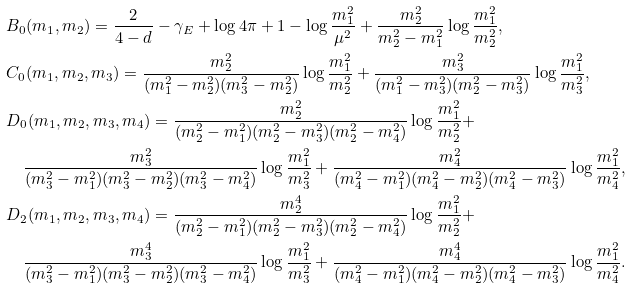Convert formula to latex. <formula><loc_0><loc_0><loc_500><loc_500>& B _ { 0 } ( m _ { 1 } , m _ { 2 } ) = \frac { 2 } { 4 - d } - \gamma _ { E } + \log 4 \pi + 1 - \log \frac { m _ { 1 } ^ { 2 } } { \mu ^ { 2 } } + \frac { m _ { 2 } ^ { 2 } } { m _ { 2 } ^ { 2 } - m _ { 1 } ^ { 2 } } \log \frac { m _ { 1 } ^ { 2 } } { m _ { 2 } ^ { 2 } } , \\ & C _ { 0 } ( m _ { 1 } , m _ { 2 } , m _ { 3 } ) = \frac { m _ { 2 } ^ { 2 } } { ( m _ { 1 } ^ { 2 } - m _ { 2 } ^ { 2 } ) ( m _ { 3 } ^ { 2 } - m _ { 2 } ^ { 2 } ) } \log \frac { m _ { 1 } ^ { 2 } } { m _ { 2 } ^ { 2 } } + \frac { m _ { 3 } ^ { 2 } } { ( m _ { 1 } ^ { 2 } - m _ { 3 } ^ { 2 } ) ( m _ { 2 } ^ { 2 } - m _ { 3 } ^ { 2 } ) } \log \frac { m _ { 1 } ^ { 2 } } { m _ { 3 } ^ { 2 } } , \\ & D _ { 0 } ( m _ { 1 } , m _ { 2 } , m _ { 3 } , m _ { 4 } ) = \frac { m _ { 2 } ^ { 2 } } { ( m _ { 2 } ^ { 2 } - m _ { 1 } ^ { 2 } ) ( m _ { 2 } ^ { 2 } - m _ { 3 } ^ { 2 } ) ( m _ { 2 } ^ { 2 } - m _ { 4 } ^ { 2 } ) } \log \frac { m _ { 1 } ^ { 2 } } { m _ { 2 } ^ { 2 } } + \\ & \quad \frac { m _ { 3 } ^ { 2 } } { ( m _ { 3 } ^ { 2 } - m _ { 1 } ^ { 2 } ) ( m _ { 3 } ^ { 2 } - m _ { 2 } ^ { 2 } ) ( m _ { 3 } ^ { 2 } - m _ { 4 } ^ { 2 } ) } \log \frac { m _ { 1 } ^ { 2 } } { m _ { 3 } ^ { 2 } } + \frac { m _ { 4 } ^ { 2 } } { ( m _ { 4 } ^ { 2 } - m _ { 1 } ^ { 2 } ) ( m _ { 4 } ^ { 2 } - m _ { 2 } ^ { 2 } ) ( m _ { 4 } ^ { 2 } - m _ { 3 } ^ { 2 } ) } \log \frac { m _ { 1 } ^ { 2 } } { m _ { 4 } ^ { 2 } } , \\ & D _ { 2 } ( m _ { 1 } , m _ { 2 } , m _ { 3 } , m _ { 4 } ) = \frac { m _ { 2 } ^ { 4 } } { ( m _ { 2 } ^ { 2 } - m _ { 1 } ^ { 2 } ) ( m _ { 2 } ^ { 2 } - m _ { 3 } ^ { 2 } ) ( m _ { 2 } ^ { 2 } - m _ { 4 } ^ { 2 } ) } \log \frac { m _ { 1 } ^ { 2 } } { m _ { 2 } ^ { 2 } } + \\ & \quad \frac { m _ { 3 } ^ { 4 } } { ( m _ { 3 } ^ { 2 } - m _ { 1 } ^ { 2 } ) ( m _ { 3 } ^ { 2 } - m _ { 2 } ^ { 2 } ) ( m _ { 3 } ^ { 2 } - m _ { 4 } ^ { 2 } ) } \log \frac { m _ { 1 } ^ { 2 } } { m _ { 3 } ^ { 2 } } + \frac { m _ { 4 } ^ { 4 } } { ( m _ { 4 } ^ { 2 } - m _ { 1 } ^ { 2 } ) ( m _ { 4 } ^ { 2 } - m _ { 2 } ^ { 2 } ) ( m _ { 4 } ^ { 2 } - m _ { 3 } ^ { 2 } ) } \log \frac { m _ { 1 } ^ { 2 } } { m _ { 4 } ^ { 2 } } .</formula> 